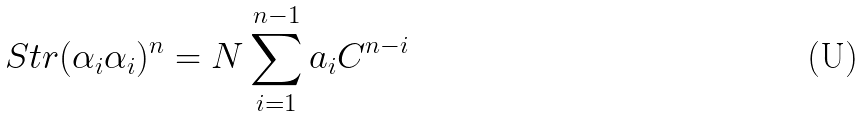Convert formula to latex. <formula><loc_0><loc_0><loc_500><loc_500>S t r ( \alpha _ { i } \alpha _ { i } ) ^ { n } = N \sum _ { i = 1 } ^ { n - 1 } a _ { i } C ^ { n - i }</formula> 